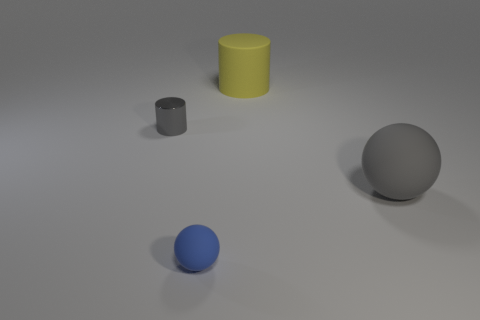Are there any other things that are made of the same material as the tiny gray object?
Make the answer very short. No. Is the tiny shiny thing the same shape as the yellow matte thing?
Provide a succinct answer. Yes. There is a large yellow matte cylinder; are there any cylinders on the left side of it?
Your answer should be very brief. Yes. What number of objects are big yellow metallic blocks or shiny things?
Your answer should be very brief. 1. How many other objects are there of the same size as the shiny cylinder?
Your response must be concise. 1. How many objects are both in front of the large cylinder and behind the large gray matte sphere?
Offer a terse response. 1. There is a gray object that is on the right side of the rubber cylinder; is its size the same as the thing that is on the left side of the blue rubber object?
Offer a very short reply. No. There is a gray thing to the left of the tiny blue matte sphere; what size is it?
Provide a succinct answer. Small. How many things are objects that are behind the blue rubber object or big rubber objects that are behind the gray metallic cylinder?
Your response must be concise. 3. Is there anything else that has the same color as the big matte cylinder?
Give a very brief answer. No. 